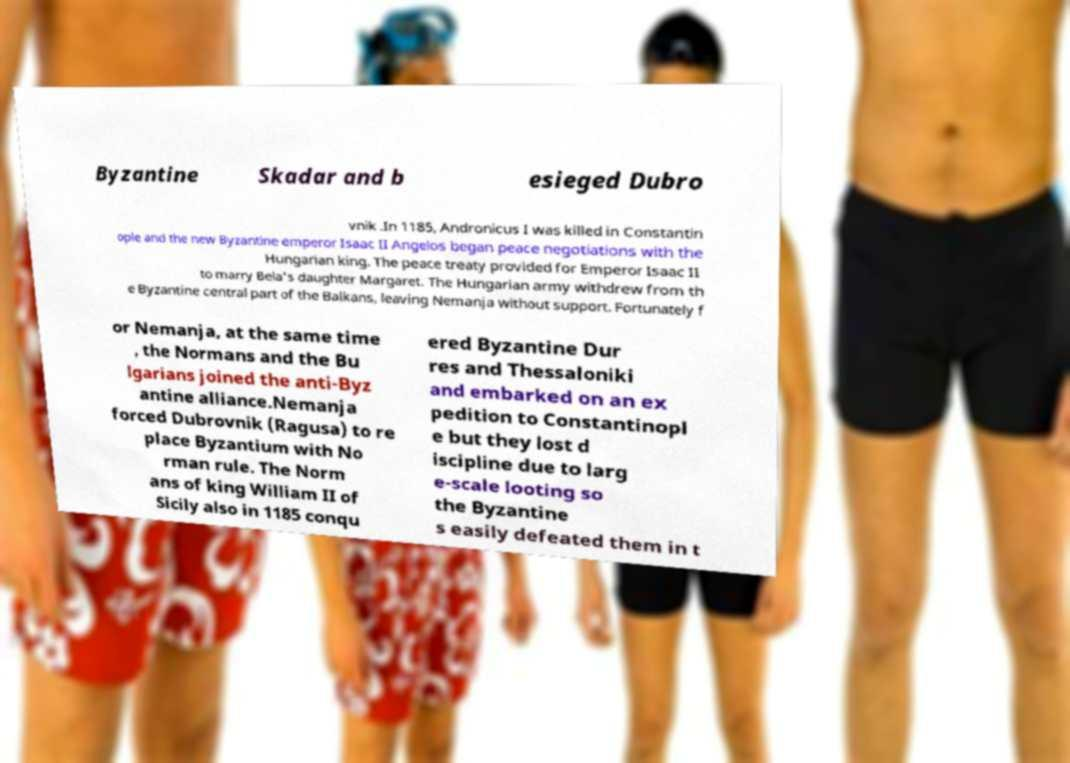I need the written content from this picture converted into text. Can you do that? Byzantine Skadar and b esieged Dubro vnik .In 1185, Andronicus I was killed in Constantin ople and the new Byzantine emperor Isaac II Angelos began peace negotiations with the Hungarian king. The peace treaty provided for Emperor Isaac II to marry Bela's daughter Margaret. The Hungarian army withdrew from th e Byzantine central part of the Balkans, leaving Nemanja without support. Fortunately f or Nemanja, at the same time , the Normans and the Bu lgarians joined the anti-Byz antine alliance.Nemanja forced Dubrovnik (Ragusa) to re place Byzantium with No rman rule. The Norm ans of king William II of Sicily also in 1185 conqu ered Byzantine Dur res and Thessaloniki and embarked on an ex pedition to Constantinopl e but they lost d iscipline due to larg e-scale looting so the Byzantine s easily defeated them in t 